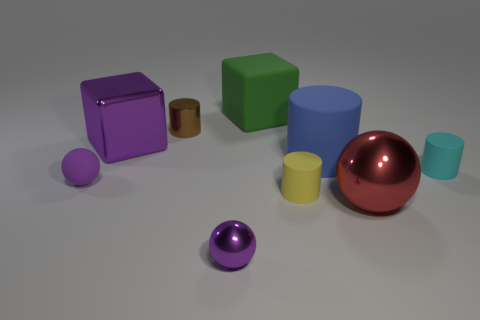Subtract 1 cylinders. How many cylinders are left? 3 Subtract all brown cylinders. How many cylinders are left? 3 Add 1 shiny things. How many objects exist? 10 Subtract all green cylinders. Subtract all purple balls. How many cylinders are left? 4 Subtract all balls. How many objects are left? 6 Subtract all purple shiny things. Subtract all tiny cyan objects. How many objects are left? 6 Add 3 large objects. How many large objects are left? 7 Add 5 gray matte cylinders. How many gray matte cylinders exist? 5 Subtract 0 blue blocks. How many objects are left? 9 